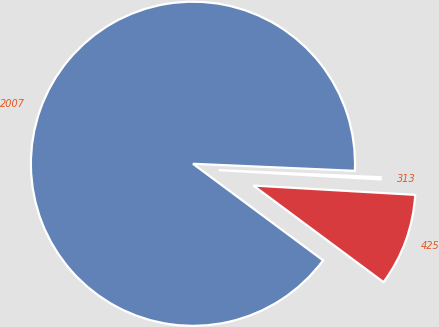Convert chart to OTSL. <chart><loc_0><loc_0><loc_500><loc_500><pie_chart><fcel>2007<fcel>425<fcel>313<nl><fcel>90.53%<fcel>9.25%<fcel>0.22%<nl></chart> 